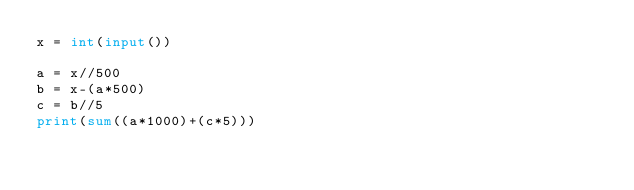<code> <loc_0><loc_0><loc_500><loc_500><_Python_>x = int(input())

a = x//500
b = x-(a*500)
c = b//5
print(sum((a*1000)+(c*5)))
</code> 